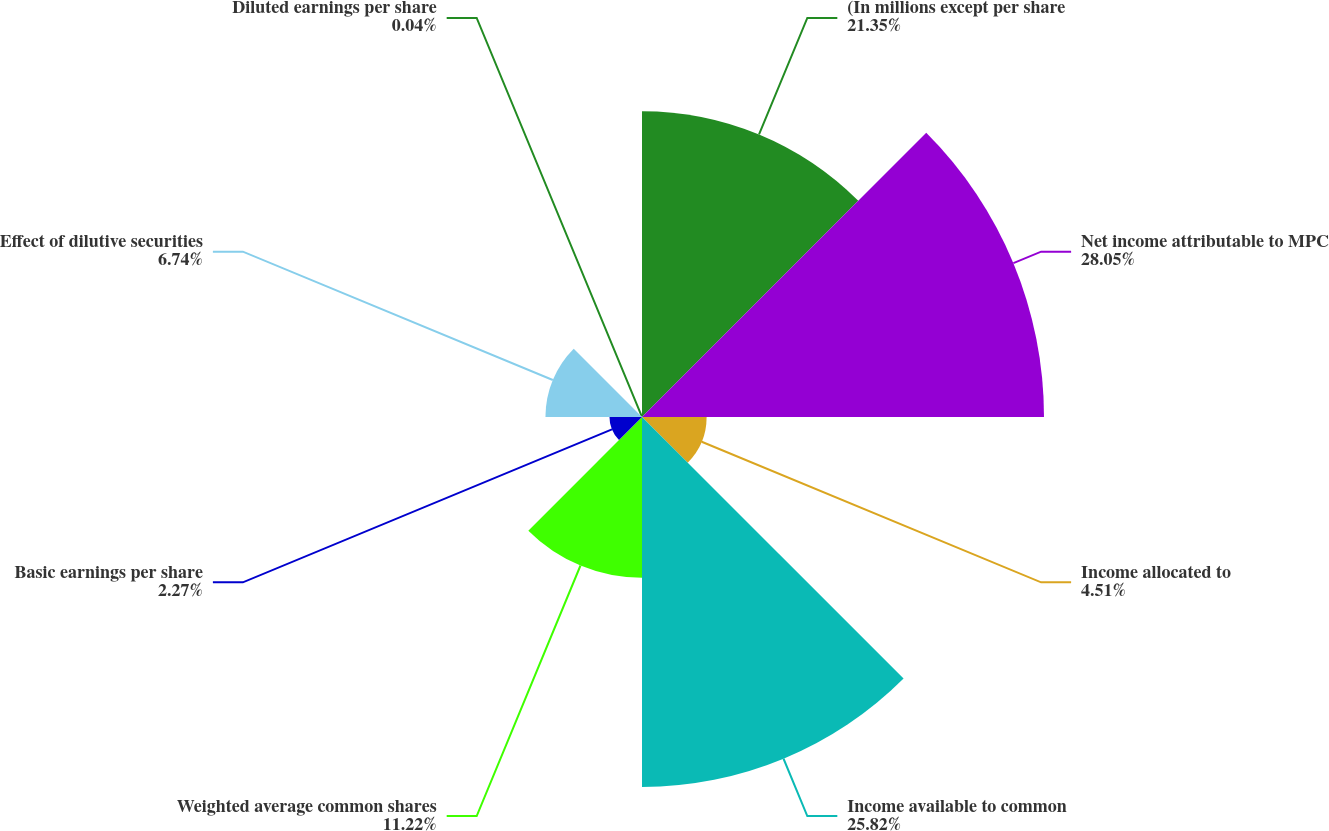Convert chart. <chart><loc_0><loc_0><loc_500><loc_500><pie_chart><fcel>(In millions except per share<fcel>Net income attributable to MPC<fcel>Income allocated to<fcel>Income available to common<fcel>Weighted average common shares<fcel>Basic earnings per share<fcel>Effect of dilutive securities<fcel>Diluted earnings per share<nl><fcel>21.35%<fcel>28.06%<fcel>4.51%<fcel>25.82%<fcel>11.22%<fcel>2.27%<fcel>6.74%<fcel>0.04%<nl></chart> 